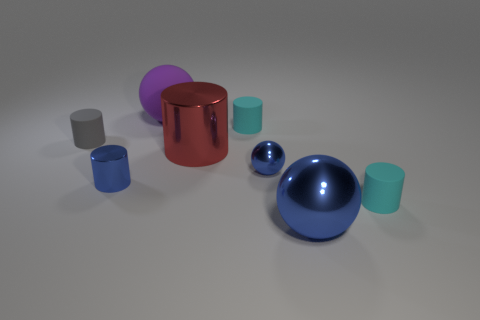Subtract all cylinders. How many objects are left? 3 Subtract all tiny balls. How many balls are left? 2 Add 4 small matte objects. How many small matte objects exist? 7 Add 2 large red metallic things. How many objects exist? 10 Subtract all blue balls. How many balls are left? 1 Subtract 0 yellow spheres. How many objects are left? 8 Subtract 3 cylinders. How many cylinders are left? 2 Subtract all blue cylinders. Subtract all blue cubes. How many cylinders are left? 4 Subtract all green balls. How many cyan cylinders are left? 2 Subtract all tiny shiny objects. Subtract all cyan rubber things. How many objects are left? 4 